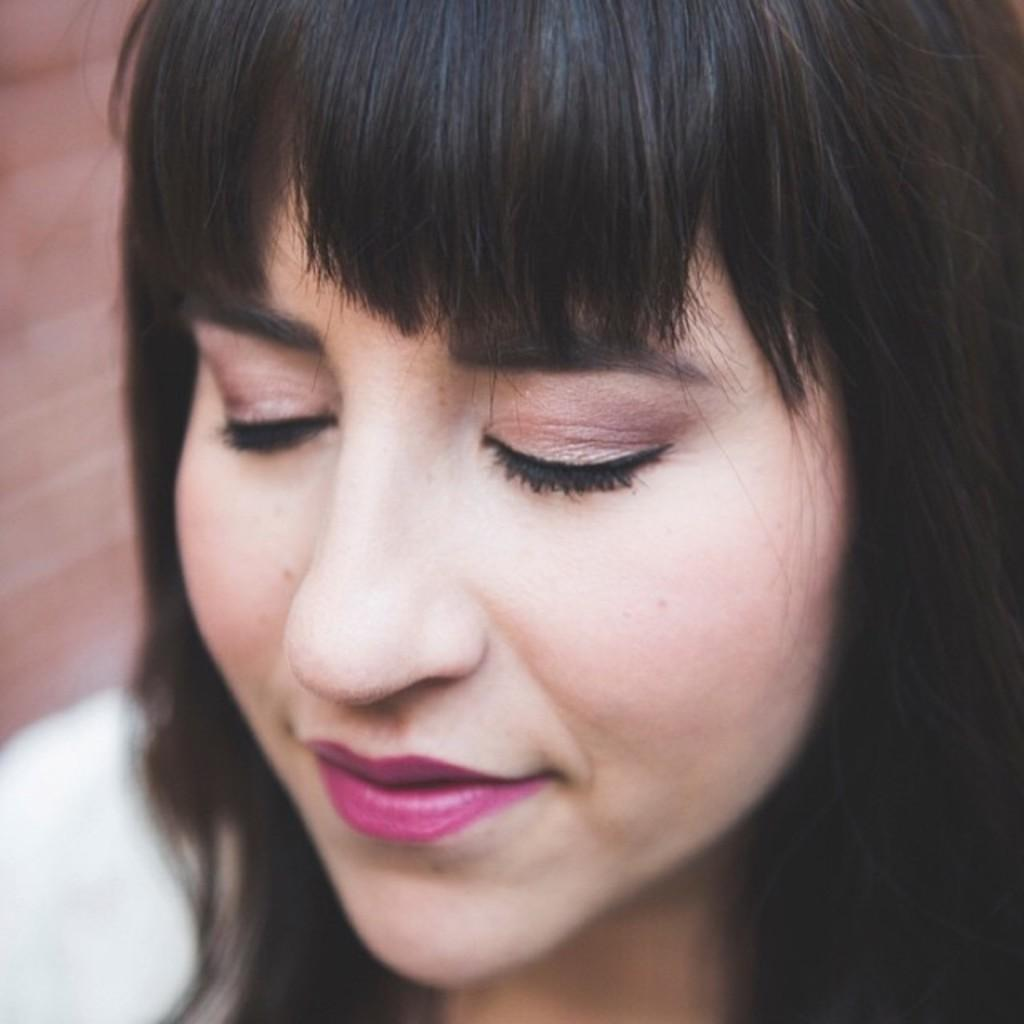Who is the main subject in the image? There is a woman in the image. In which direction is the woman facing? The woman is facing towards the left. What is the woman doing with her eyes? The woman has her eyes closed. What type of cheese can be seen on the woman's face in the image? There is no cheese present in the image; it only features a woman with her eyes closed. 